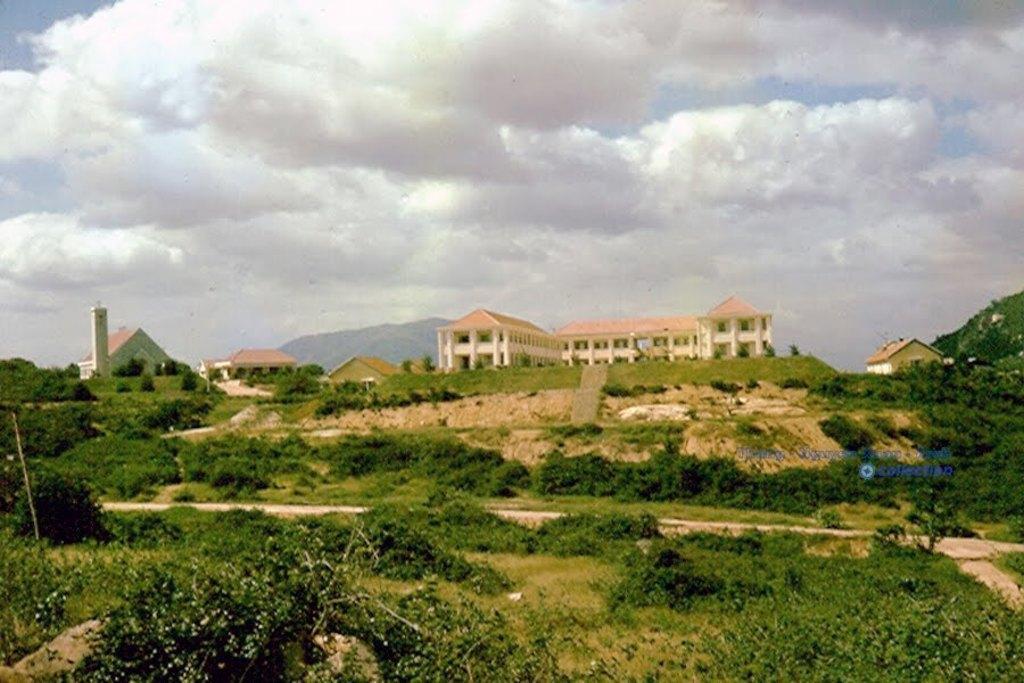How would you summarize this image in a sentence or two? In this image we can see many buildings. There are many trees and plants in the image. There is a grassy land in the image. We can see the clouds in the image. There is some text at the right side of the image. 